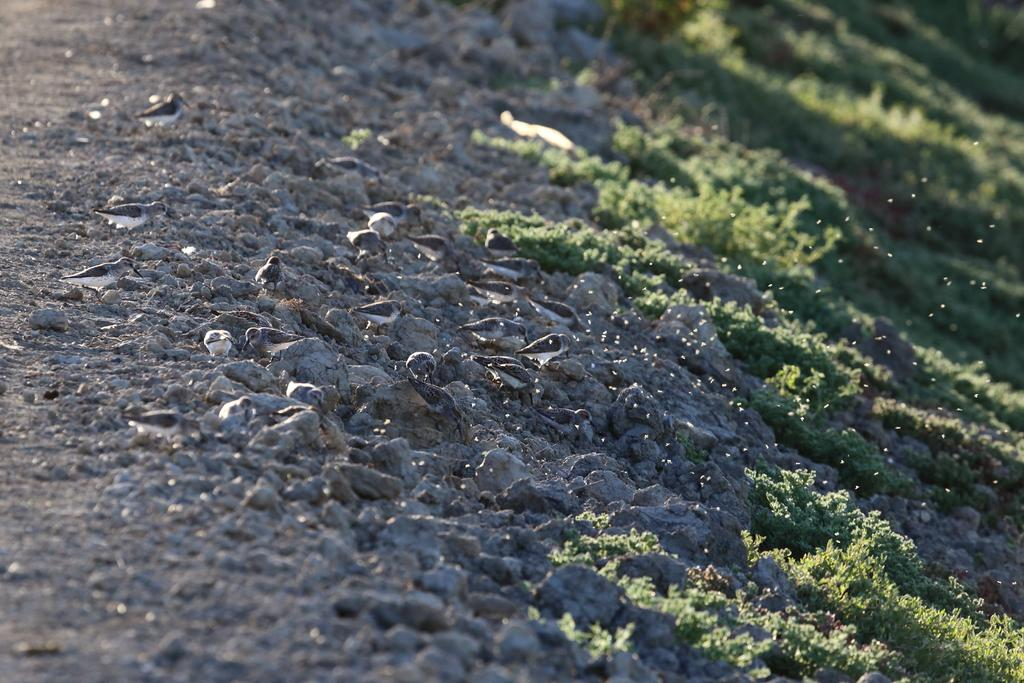What type of natural elements can be seen in the image? There are small stones and grass visible in the image. Can you describe the stones in the image? The stones in the image are small in size. What is located beside the stones in the image? There is grass beside the stones in the image. What type of trouble is the tramp causing in the image? There is no tramp or trouble present in the image; it only features small stones and grass. How many feet can be seen in the image? There are no feet visible in the image. 